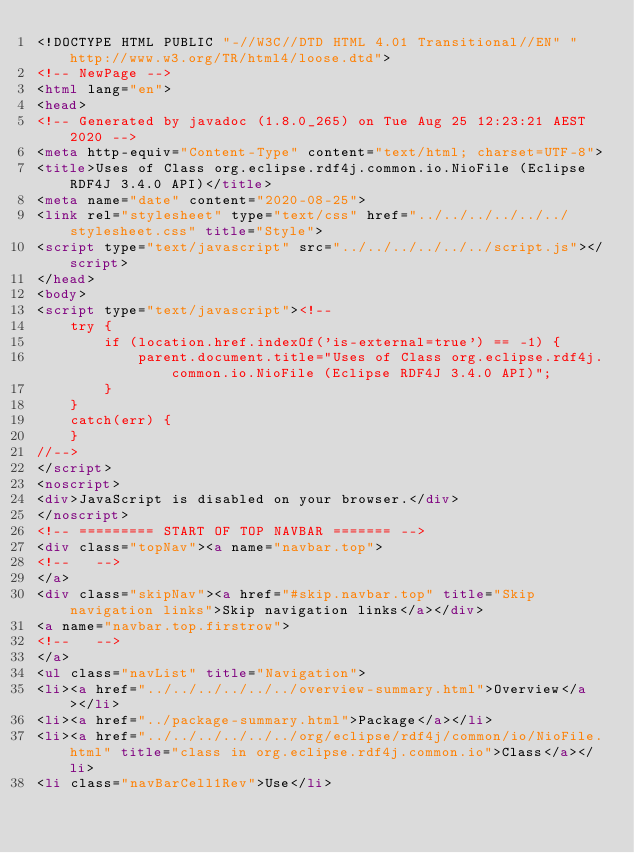Convert code to text. <code><loc_0><loc_0><loc_500><loc_500><_HTML_><!DOCTYPE HTML PUBLIC "-//W3C//DTD HTML 4.01 Transitional//EN" "http://www.w3.org/TR/html4/loose.dtd">
<!-- NewPage -->
<html lang="en">
<head>
<!-- Generated by javadoc (1.8.0_265) on Tue Aug 25 12:23:21 AEST 2020 -->
<meta http-equiv="Content-Type" content="text/html; charset=UTF-8">
<title>Uses of Class org.eclipse.rdf4j.common.io.NioFile (Eclipse RDF4J 3.4.0 API)</title>
<meta name="date" content="2020-08-25">
<link rel="stylesheet" type="text/css" href="../../../../../../stylesheet.css" title="Style">
<script type="text/javascript" src="../../../../../../script.js"></script>
</head>
<body>
<script type="text/javascript"><!--
    try {
        if (location.href.indexOf('is-external=true') == -1) {
            parent.document.title="Uses of Class org.eclipse.rdf4j.common.io.NioFile (Eclipse RDF4J 3.4.0 API)";
        }
    }
    catch(err) {
    }
//-->
</script>
<noscript>
<div>JavaScript is disabled on your browser.</div>
</noscript>
<!-- ========= START OF TOP NAVBAR ======= -->
<div class="topNav"><a name="navbar.top">
<!--   -->
</a>
<div class="skipNav"><a href="#skip.navbar.top" title="Skip navigation links">Skip navigation links</a></div>
<a name="navbar.top.firstrow">
<!--   -->
</a>
<ul class="navList" title="Navigation">
<li><a href="../../../../../../overview-summary.html">Overview</a></li>
<li><a href="../package-summary.html">Package</a></li>
<li><a href="../../../../../../org/eclipse/rdf4j/common/io/NioFile.html" title="class in org.eclipse.rdf4j.common.io">Class</a></li>
<li class="navBarCell1Rev">Use</li></code> 